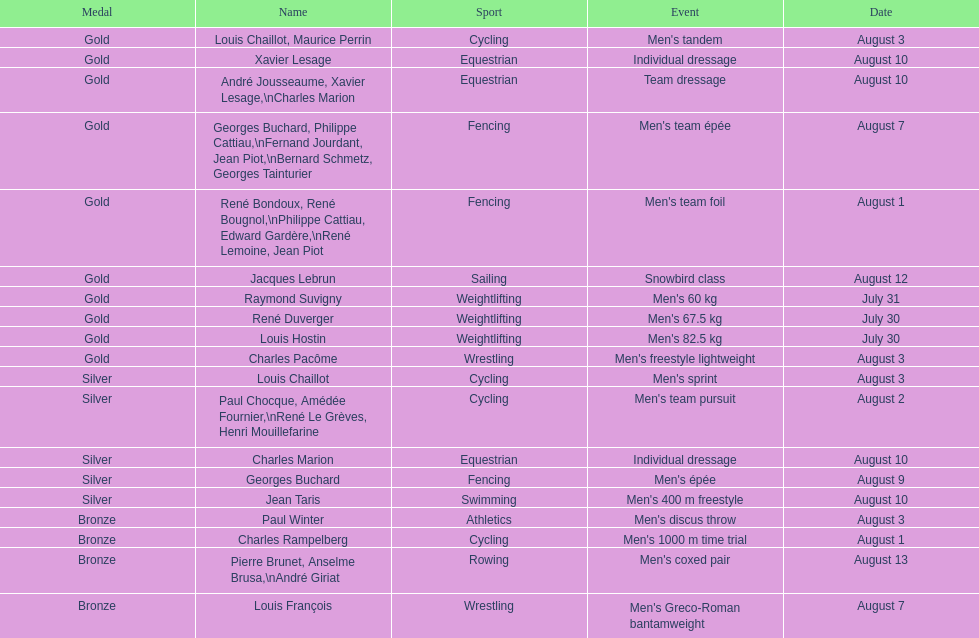What event is listed right before team dressage? Individual dressage. 